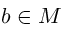<formula> <loc_0><loc_0><loc_500><loc_500>b \in M</formula> 